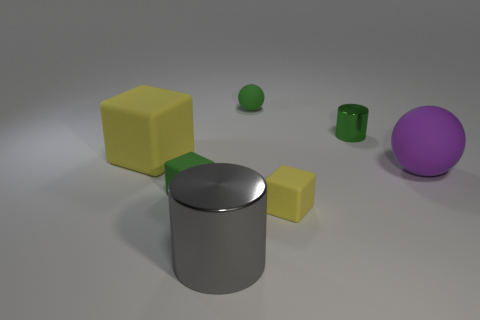Add 2 large purple rubber objects. How many objects exist? 9 Subtract all blocks. How many objects are left? 4 Subtract all big gray cubes. Subtract all green blocks. How many objects are left? 6 Add 7 small blocks. How many small blocks are left? 9 Add 4 tiny brown things. How many tiny brown things exist? 4 Subtract 1 purple balls. How many objects are left? 6 